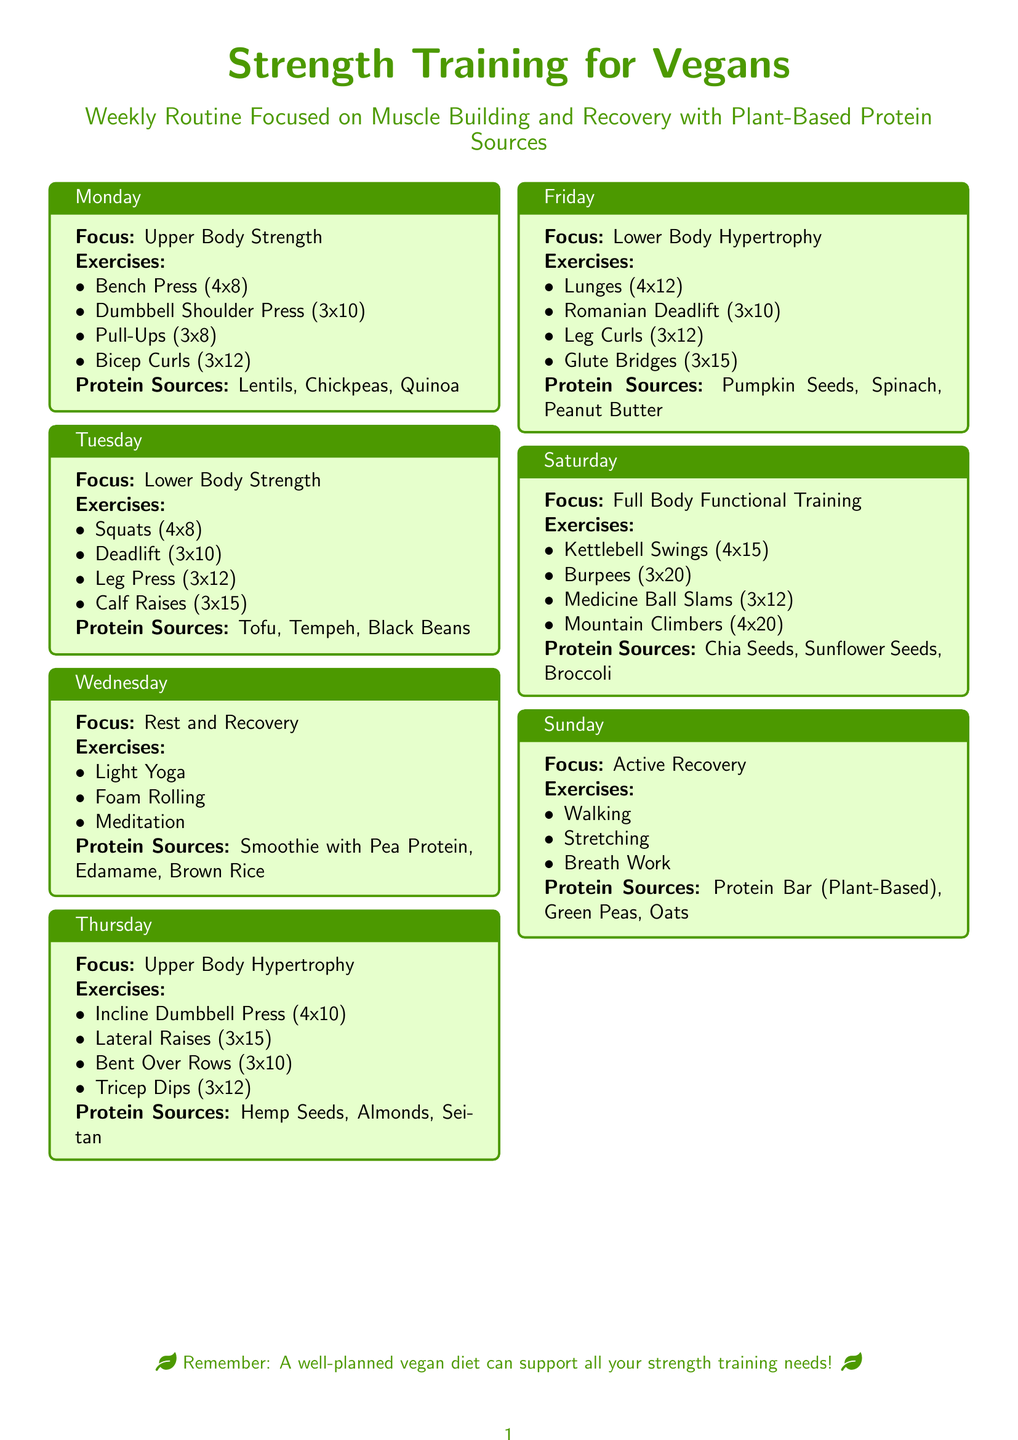what exercises are included in Monday's routine? Monday's routine includes a Bench Press, Dumbbell Shoulder Press, Pull-Ups, and Bicep Curls.
Answer: Bench Press, Dumbbell Shoulder Press, Pull-Ups, Bicep Curls how many repetitions are recommended for Squats? The recommended repetitions for Squats in the Tuesday routine is 8.
Answer: 8 what is emphasized in the Wednesday session? The Wednesday session emphasizes Rest and Recovery activities such as Light Yoga, Foam Rolling, and Meditation.
Answer: Rest and Recovery which plant-based protein source is listed for Friday's workout? For Friday's Lower Body Hypertrophy workout, the listed protein source is Pumpkin Seeds.
Answer: Pumpkin Seeds how many exercises are mentioned for Saturday's Full Body Functional Training? There are four exercises mentioned for Saturday's Full Body Functional Training.
Answer: 4 what aspect of recovery is highlighted on Sunday? The Sunday routine highlights Active Recovery activities, including Walking and Stretching.
Answer: Active Recovery which exercise is performed with the highest number of repetitions on Monday? The exercise performed with the highest number of repetitions on Monday is Bicep Curls with 12 repetitions.
Answer: Bicep Curls 12 what type of training is focused on Thursday? The training focus on Thursday is Upper Body Hypertrophy.
Answer: Upper Body Hypertrophy name one protein source listed for Tuesday's workout. One protein source listed for Tuesday's workout is Tofu.
Answer: Tofu 